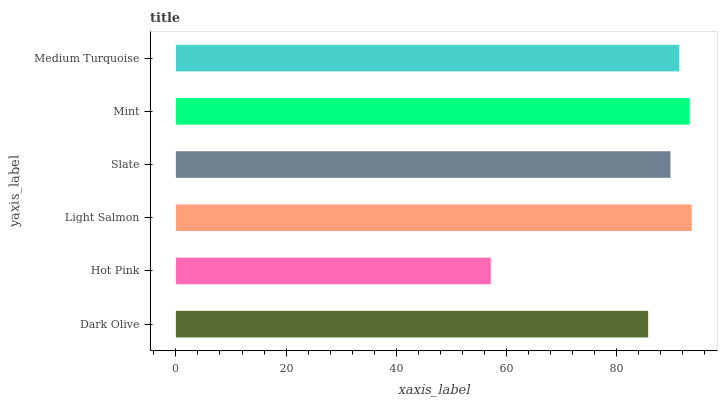Is Hot Pink the minimum?
Answer yes or no. Yes. Is Light Salmon the maximum?
Answer yes or no. Yes. Is Light Salmon the minimum?
Answer yes or no. No. Is Hot Pink the maximum?
Answer yes or no. No. Is Light Salmon greater than Hot Pink?
Answer yes or no. Yes. Is Hot Pink less than Light Salmon?
Answer yes or no. Yes. Is Hot Pink greater than Light Salmon?
Answer yes or no. No. Is Light Salmon less than Hot Pink?
Answer yes or no. No. Is Medium Turquoise the high median?
Answer yes or no. Yes. Is Slate the low median?
Answer yes or no. Yes. Is Mint the high median?
Answer yes or no. No. Is Mint the low median?
Answer yes or no. No. 